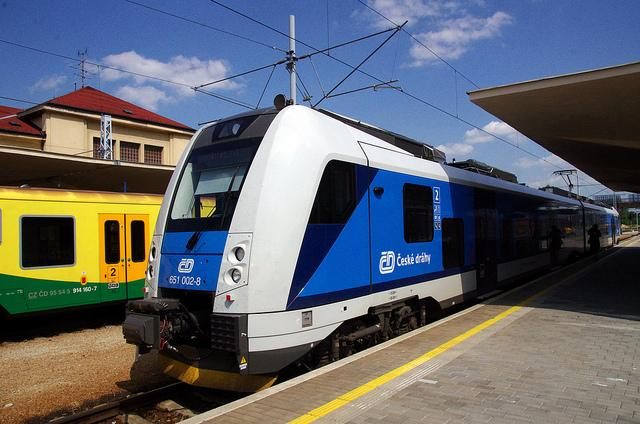Where is the train from?

Choices:
A) czech republic
B) america
C) china
D) japan czech republic 